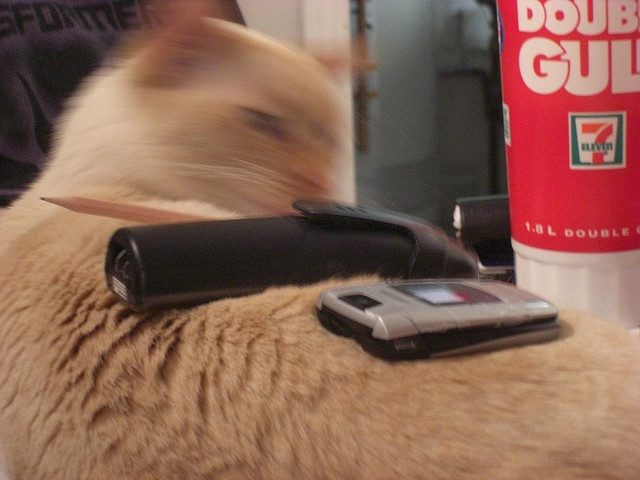Describe the objects in this image and their specific colors. I can see cat in black, gray, and tan tones, cup in black, brown, tan, and darkgray tones, and cell phone in black, darkgray, and gray tones in this image. 